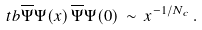Convert formula to latex. <formula><loc_0><loc_0><loc_500><loc_500>\ t b { \overline { \Psi } \Psi ( x ) \, \overline { \Psi } \Psi ( 0 ) } \, \sim \, x ^ { - 1 / N _ { c } } \, .</formula> 